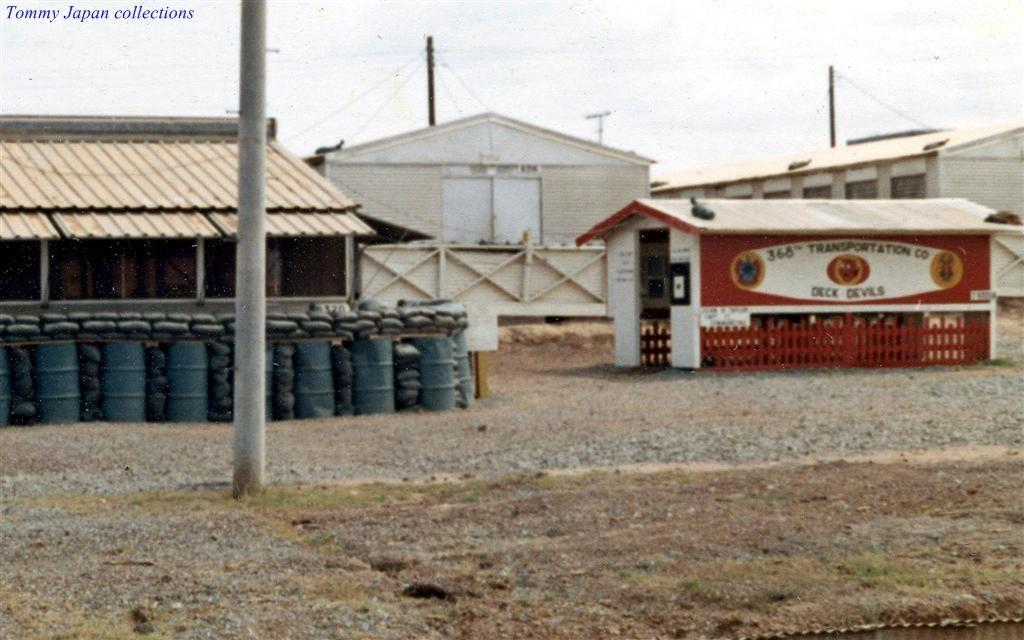What type of structures can be seen in the image? There are buildings in the image. What musical instruments are present in the image? There are drums in blue and black color in the image. What other objects can be seen in the image? There are poles in the image. What can be seen in the background of the image? The sky is visible in the background of the image, and it appears to be white. What type of food is being prepared by the maid in the image? There is no maid or food preparation present in the image. 